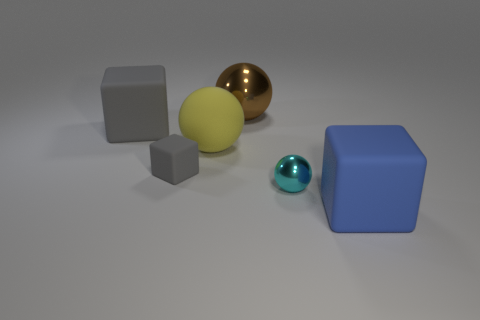Are there any big blue matte blocks in front of the yellow thing?
Ensure brevity in your answer.  Yes. What is the shape of the big blue rubber object?
Provide a succinct answer. Cube. What shape is the small gray matte object in front of the big matte cube to the left of the large sphere that is on the right side of the large yellow thing?
Give a very brief answer. Cube. How many other objects are the same shape as the big blue thing?
Your answer should be very brief. 2. The large block that is behind the large matte cube that is in front of the cyan metal thing is made of what material?
Provide a short and direct response. Rubber. Is there anything else that has the same size as the blue object?
Your answer should be compact. Yes. Does the yellow thing have the same material as the big thing to the left of the small gray object?
Offer a very short reply. Yes. The object that is both behind the large blue object and on the right side of the brown object is made of what material?
Make the answer very short. Metal. There is a large block that is on the right side of the gray block that is behind the yellow thing; what color is it?
Your answer should be compact. Blue. There is a big object that is on the left side of the big yellow matte thing; what material is it?
Your answer should be very brief. Rubber. 